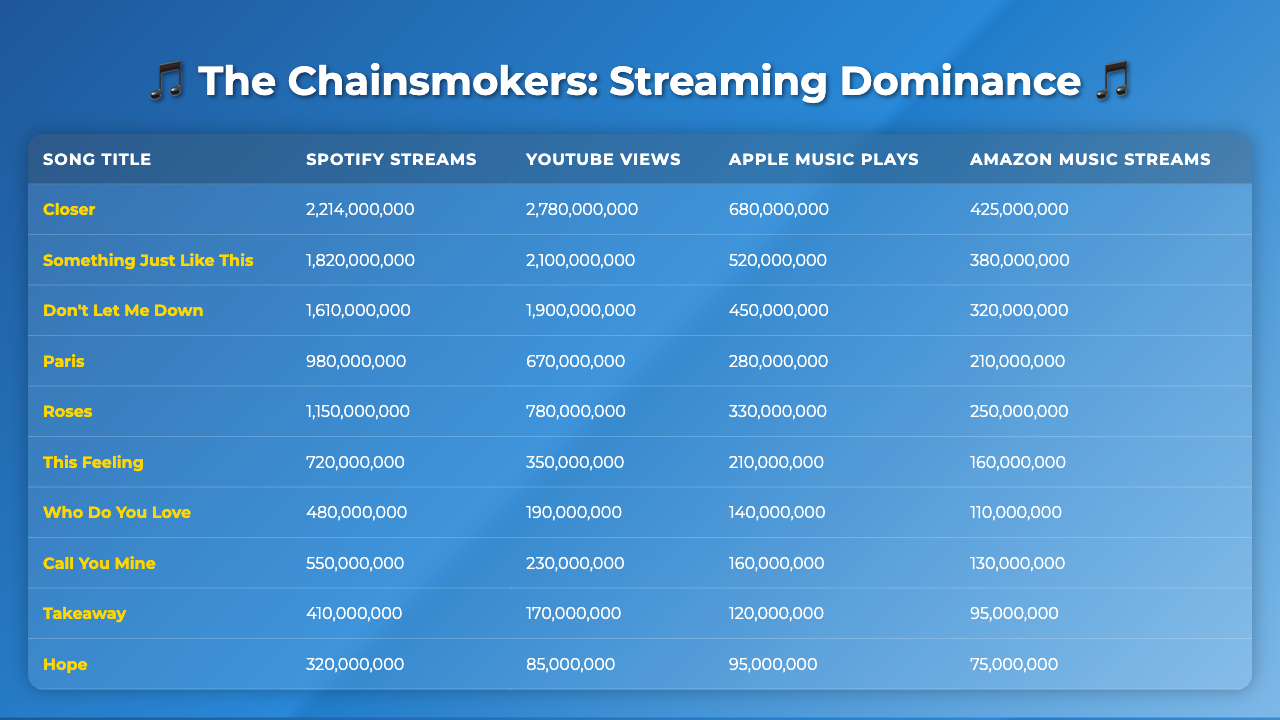What is the total number of Spotify streams for all songs combined? To find the total Spotify streams, I will sum the individual streams of each song: 2,214,000,000 + 1,820,000,000 + 1,610,000,000 + 980,000,000 + 1,150,000,000 + 720,000,000 + 480,000,000 + 550,000,000 + 410,000,000 + 320,000,000 = 10,426,000,000
Answer: 10,426,000,000 Which song has the highest number of YouTube views? By checking the YouTube views column, I see that "Closer" has the highest views with 2,780,000,000.
Answer: Closer How many more streams does "Don't Let Me Down" have on Spotify compared to "Hope"? I will calculate the difference in Spotify streams: 1,610,000,000 (Don't Let Me Down) - 320,000,000 (Hope) = 1,290,000,000.
Answer: 1,290,000,000 Is "Something Just Like This" more popular on YouTube than "Paris"? Comparing their YouTube views, "Something Just Like This" has 2,100,000,000 views while "Paris" has 670,000,000. Yes, it is more popular.
Answer: Yes What is the average Apple Music plays for the songs listed? To find the average, I will sum the Apple Music plays (680,000,000 + 520,000,000 + 450,000,000 + 280,000,000 + 330,000,000 + 210,000,000 + 140,000,000 + 160,000,000 + 120,000,000 + 95,000,000 = 2,505,000,000) and divide by 10 (the number of songs): 2,505,000,000 / 10 = 250,500,000.
Answer: 250,500,000 Which platform has the least number of streams for the song "Takeaway"? Looking at the table, "Takeaway" has 95,000,000 streams on Amazon Music, which is the least compared to its streams on other platforms.
Answer: Amazon Music What percentage of the total streams on Spotify comes from the song "Roses"? The number of Spotify streams for "Roses" is 1,150,000,000. The total from earlier is 10,426,000,000. The percentage is calculated as (1,150,000,000 / 10,426,000,000) * 100 = 11.03%.
Answer: 11.03% Is the combined figure of Spotify and YouTube views for "This Feeling" greater than the combined figure for "Call You Mine"? For "This Feeling", Spotify + YouTube views = 720,000,000 + 350,000,000 = 1,070,000,000. For "Call You Mine", it is 550,000,000 + 230,000,000 = 780,000,000. Since 1,070,000,000 > 780,000,000, the statement is true.
Answer: Yes What song has the most streams on Amazon Music? By checking the Amazon Music streams column, "Closer" has 425,000,000 streams, which is the highest among all songs.
Answer: Closer What is the difference in total streams between the song with the most Spotify streams and the song with the least? The song with the most Spotify streams is "Closer" with 2,214,000,000, and the one with the least is "Hope" with 320,000,000. The difference is 2,214,000,000 - 320,000,000 = 1,894,000,000.
Answer: 1,894,000,000 Which song would you say is the least popular based on total streaming numbers across all platforms? I will sum up the streams for each song across all platforms and identify the lowest total. "Hope" sums to 320,000,000 (Spotify) + 85,000,000 (YouTube) + 95,000,000 (Apple Music) + 75,000,000 (Amazon Music) = 575,000,000, making it the least popular.
Answer: Hope 